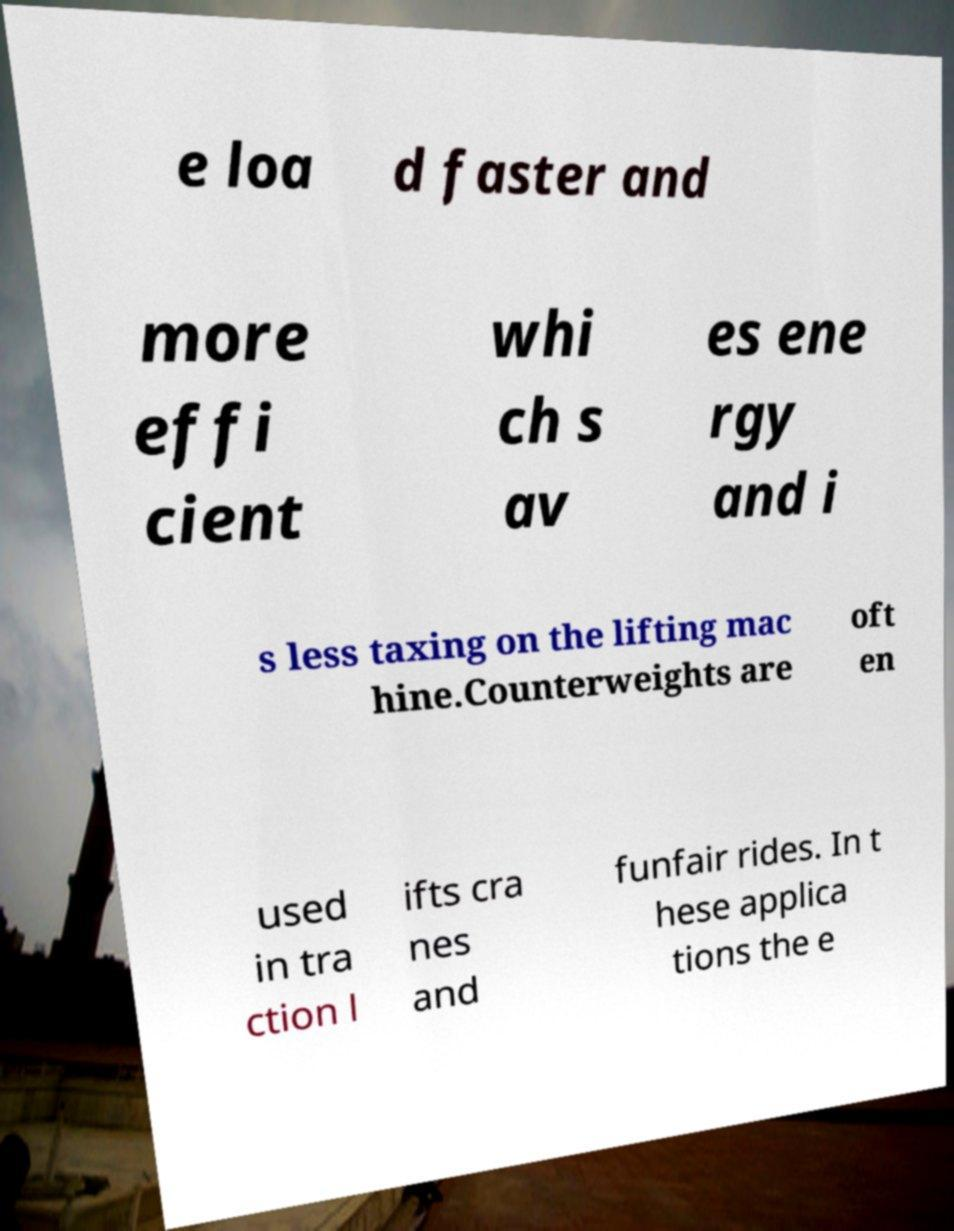There's text embedded in this image that I need extracted. Can you transcribe it verbatim? e loa d faster and more effi cient whi ch s av es ene rgy and i s less taxing on the lifting mac hine.Counterweights are oft en used in tra ction l ifts cra nes and funfair rides. In t hese applica tions the e 